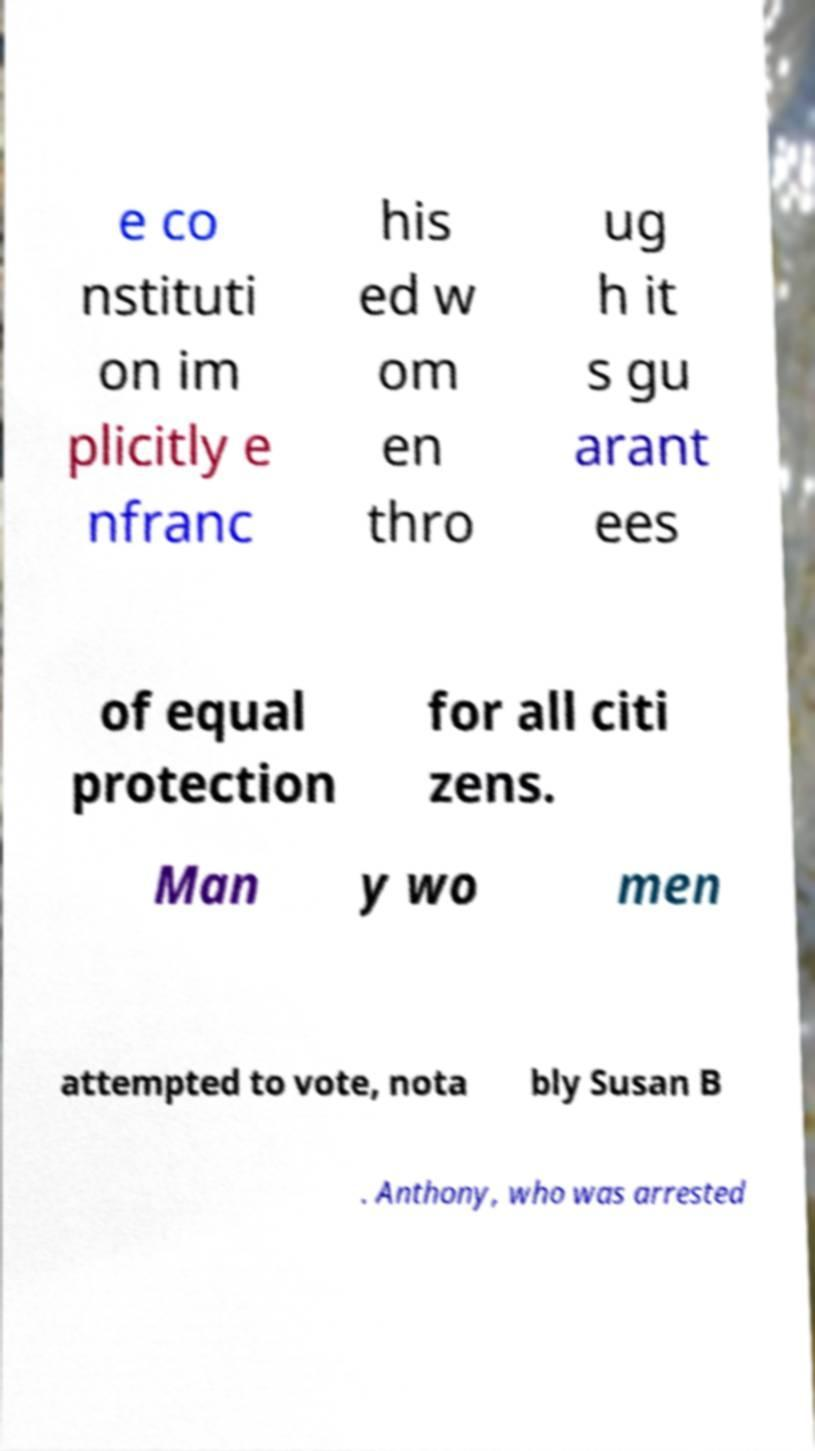Can you read and provide the text displayed in the image?This photo seems to have some interesting text. Can you extract and type it out for me? e co nstituti on im plicitly e nfranc his ed w om en thro ug h it s gu arant ees of equal protection for all citi zens. Man y wo men attempted to vote, nota bly Susan B . Anthony, who was arrested 